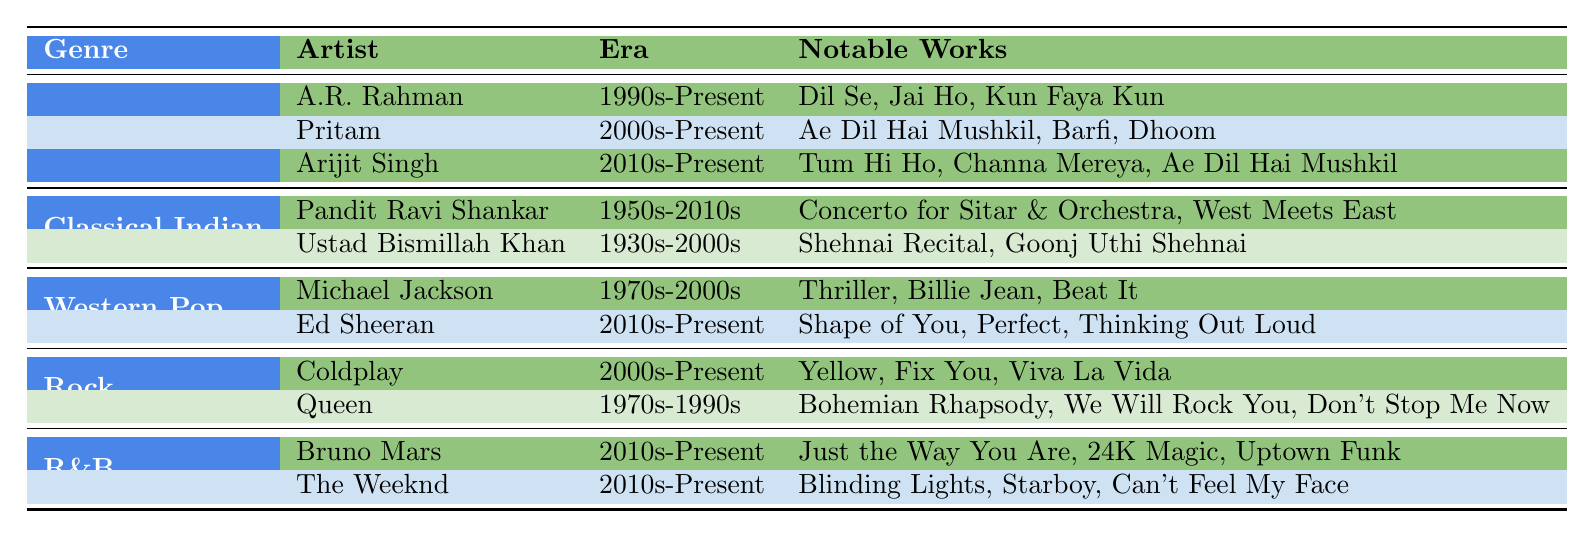What are the notable works of A.R. Rahman? A.R. Rahman's notable works listed in the table are "Dil Se," "Jai Ho," and "Kun Faya Kun."
Answer: Dil Se, Jai Ho, Kun Faya Kun Who is the artist from the R&B genre listed in the table? The R&B genre features two artists: Bruno Mars and The Weeknd.
Answer: Bruno Mars and The Weeknd Which genre has artists from the 1930s to the 2000s? The "Classical Indian" genre has Ustad Bismillah Khan, who was active from the 1930s to the 2000s.
Answer: Classical Indian Is Coldplay's era earlier than the 2000s? No, Coldplay's era is listed as 2000s-Present, which indicates that they started their career from 2000 onwards.
Answer: No How many artists are listed under the Western Pop genre? There are two artists listed under the Western Pop genre: Michael Jackson and Ed Sheeran.
Answer: 2 Which artist has the earliest starting era in this table? Ustad Bismillah Khan from the Classical Indian genre has an era starting in the 1930s.
Answer: Ustad Bismillah Khan What is the total number of artists listed across all genres? There are 10 artists listed in total: 3 from Bollywood, 2 from Classical Indian, 2 from Western Pop, 2 from Rock, and 2 from R&B, which sums up to 10.
Answer: 10 Which genre features both contemporary and historical artists? The "Classical Indian" genre includes both historical artists like Ustad Bismillah Khan and contemporary artists such as Pandit Ravi Shankar.
Answer: Classical Indian Are there any artists listed that have collaborated with Ankit Tiwari? The table does not provide information regarding collaborations, so we cannot determine if any listed artists have collaborated with Ankit Tiwari.
Answer: Unknown Which genre has the most artists listed in the table? The "Bollywood" genre has the most artists listed, with three artists: A.R. Rahman, Pritam, and Arijit Singh.
Answer: Bollywood 